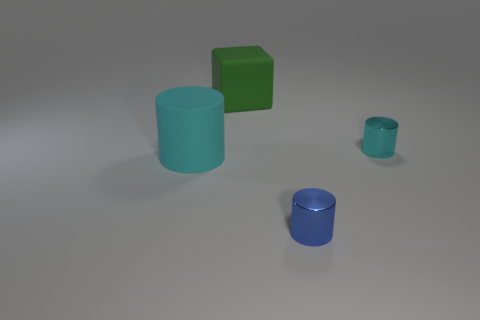What material is the cyan cylinder that is to the left of the small shiny cylinder that is in front of the big object that is in front of the large green matte object made of?
Provide a succinct answer. Rubber. Is there a green thing that has the same size as the blue cylinder?
Ensure brevity in your answer.  No. There is a green object; what shape is it?
Your response must be concise. Cube. What number of cylinders are cyan things or red matte things?
Keep it short and to the point. 2. Are there an equal number of big green cubes right of the small blue object and big things behind the small cyan cylinder?
Ensure brevity in your answer.  No. What number of green cubes are behind the tiny metal cylinder in front of the cyan thing on the right side of the large cyan cylinder?
Your response must be concise. 1. There is a big rubber cylinder; is it the same color as the tiny metallic cylinder that is behind the big matte cylinder?
Ensure brevity in your answer.  Yes. Are there more big cyan cylinders that are in front of the matte block than gray rubber blocks?
Make the answer very short. Yes. What number of things are either large matte objects that are behind the large matte cylinder or objects on the left side of the blue cylinder?
Make the answer very short. 2. There is a object that is the same material as the small cyan cylinder; what size is it?
Provide a succinct answer. Small. 